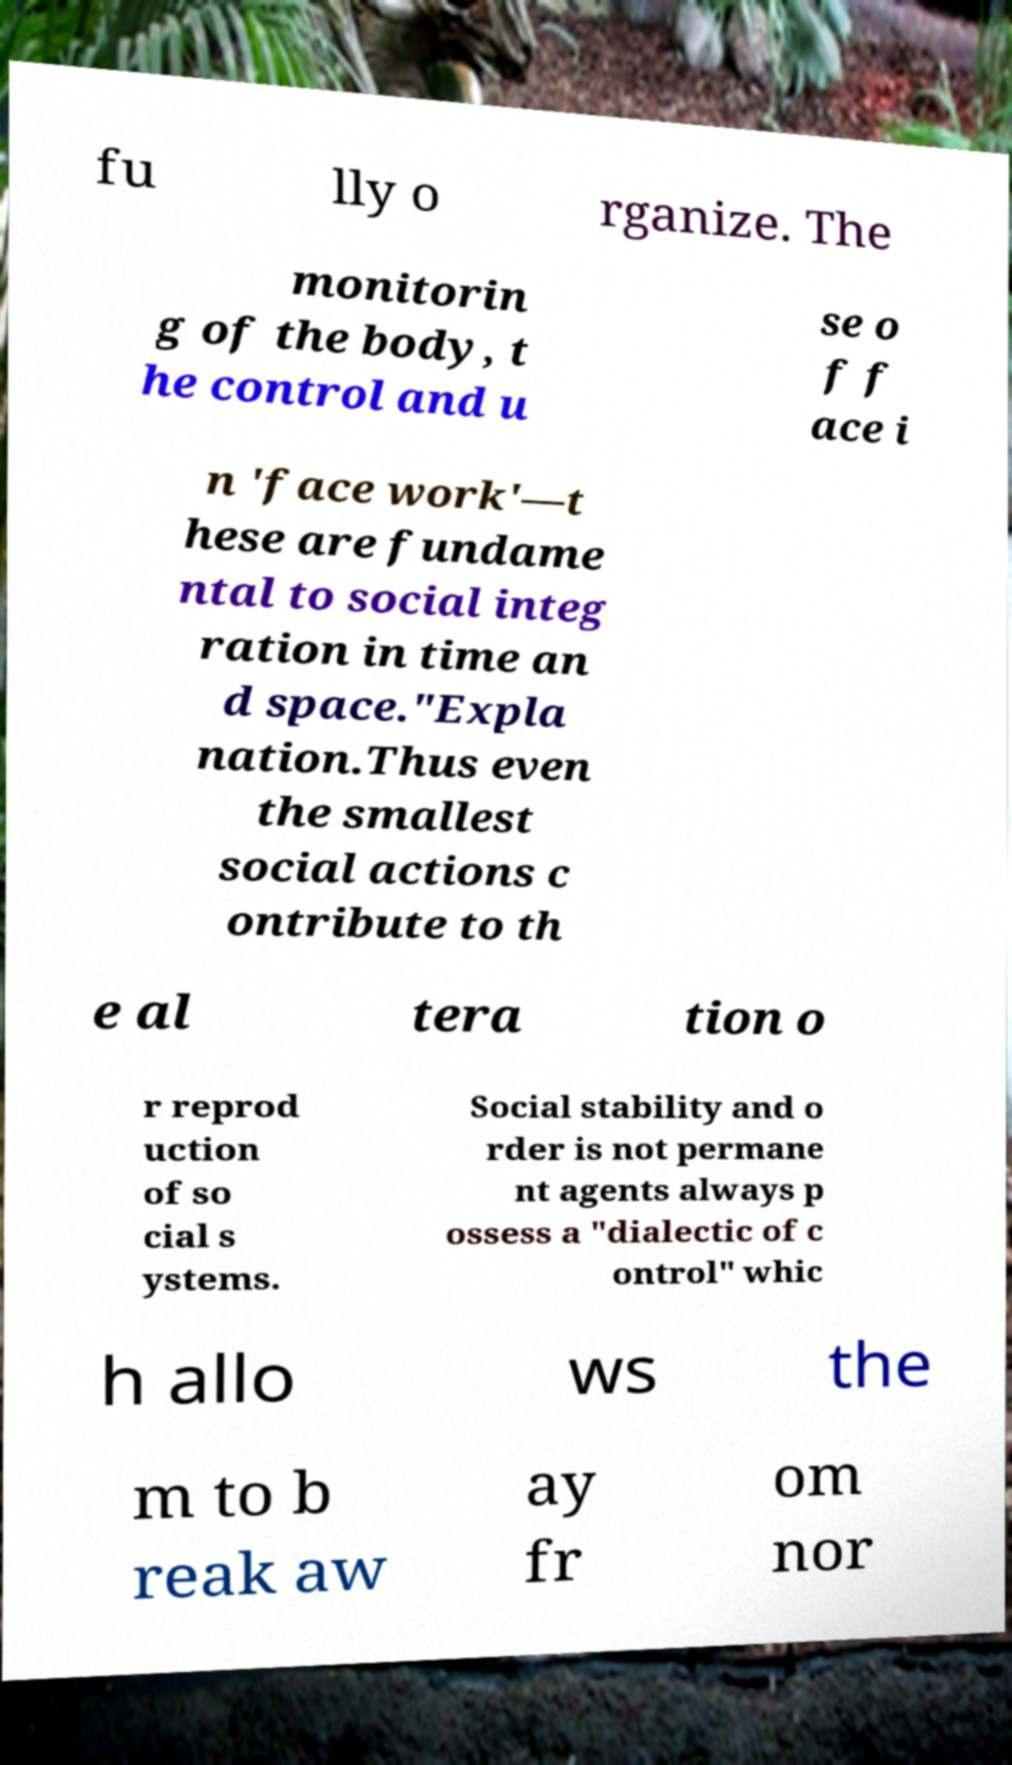Can you accurately transcribe the text from the provided image for me? fu lly o rganize. The monitorin g of the body, t he control and u se o f f ace i n 'face work'—t hese are fundame ntal to social integ ration in time an d space."Expla nation.Thus even the smallest social actions c ontribute to th e al tera tion o r reprod uction of so cial s ystems. Social stability and o rder is not permane nt agents always p ossess a "dialectic of c ontrol" whic h allo ws the m to b reak aw ay fr om nor 